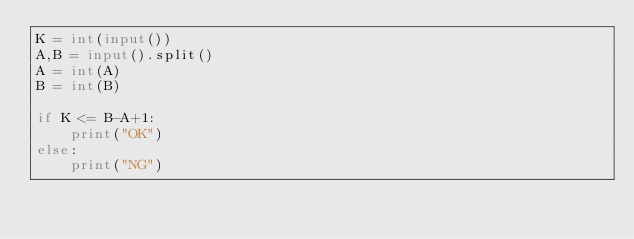Convert code to text. <code><loc_0><loc_0><loc_500><loc_500><_Python_>K = int(input())
A,B = input().split()
A = int(A)
B = int(B)

if K <= B-A+1:
    print("OK")
else:
    print("NG")</code> 